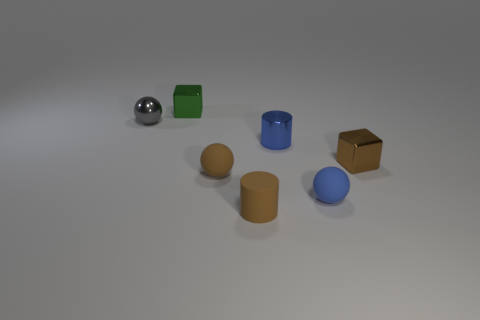Subtract all rubber balls. How many balls are left? 1 Add 1 tiny gray shiny cylinders. How many objects exist? 8 Subtract 1 balls. How many balls are left? 2 Subtract all blue spheres. How many spheres are left? 2 Subtract all cylinders. How many objects are left? 5 Add 5 tiny blue metallic things. How many tiny blue metallic things exist? 6 Subtract 0 blue cubes. How many objects are left? 7 Subtract all gray spheres. Subtract all red cubes. How many spheres are left? 2 Subtract all green objects. Subtract all small blue shiny things. How many objects are left? 5 Add 7 metal balls. How many metal balls are left? 8 